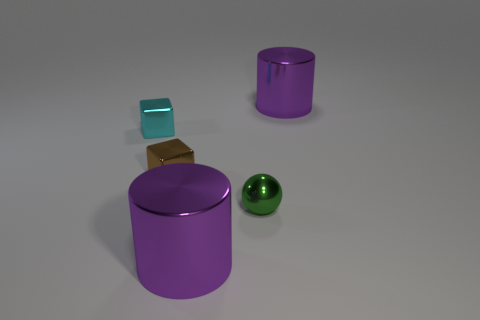Is the color of the large object on the left side of the ball the same as the metal cylinder behind the small green ball?
Keep it short and to the point. Yes. There is a shiny ball that is the same size as the cyan metallic block; what color is it?
Keep it short and to the point. Green. Are there an equal number of cyan metallic blocks in front of the small green object and big purple shiny things behind the brown metal object?
Your response must be concise. No. How many objects are either small cyan cubes or purple things?
Your response must be concise. 3. Is the number of tiny brown metallic blocks less than the number of big yellow matte things?
Your answer should be very brief. No. What size is the green thing?
Provide a short and direct response. Small. The small green shiny object is what shape?
Your answer should be compact. Sphere. Is there any other thing that has the same material as the cyan cube?
Your response must be concise. Yes. Are there any large purple shiny cylinders that are left of the big cylinder that is behind the large cylinder that is in front of the green metal sphere?
Provide a succinct answer. Yes. What number of tiny objects are green things or metallic blocks?
Your answer should be compact. 3. 